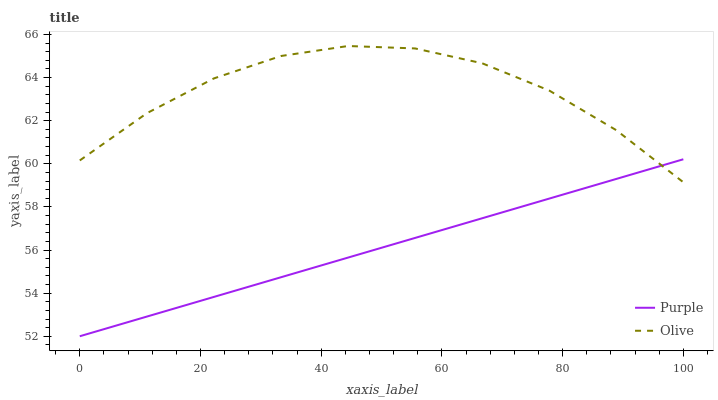Does Purple have the minimum area under the curve?
Answer yes or no. Yes. Does Olive have the maximum area under the curve?
Answer yes or no. Yes. Does Olive have the minimum area under the curve?
Answer yes or no. No. Is Purple the smoothest?
Answer yes or no. Yes. Is Olive the roughest?
Answer yes or no. Yes. Is Olive the smoothest?
Answer yes or no. No. Does Purple have the lowest value?
Answer yes or no. Yes. Does Olive have the lowest value?
Answer yes or no. No. Does Olive have the highest value?
Answer yes or no. Yes. Does Purple intersect Olive?
Answer yes or no. Yes. Is Purple less than Olive?
Answer yes or no. No. Is Purple greater than Olive?
Answer yes or no. No. 